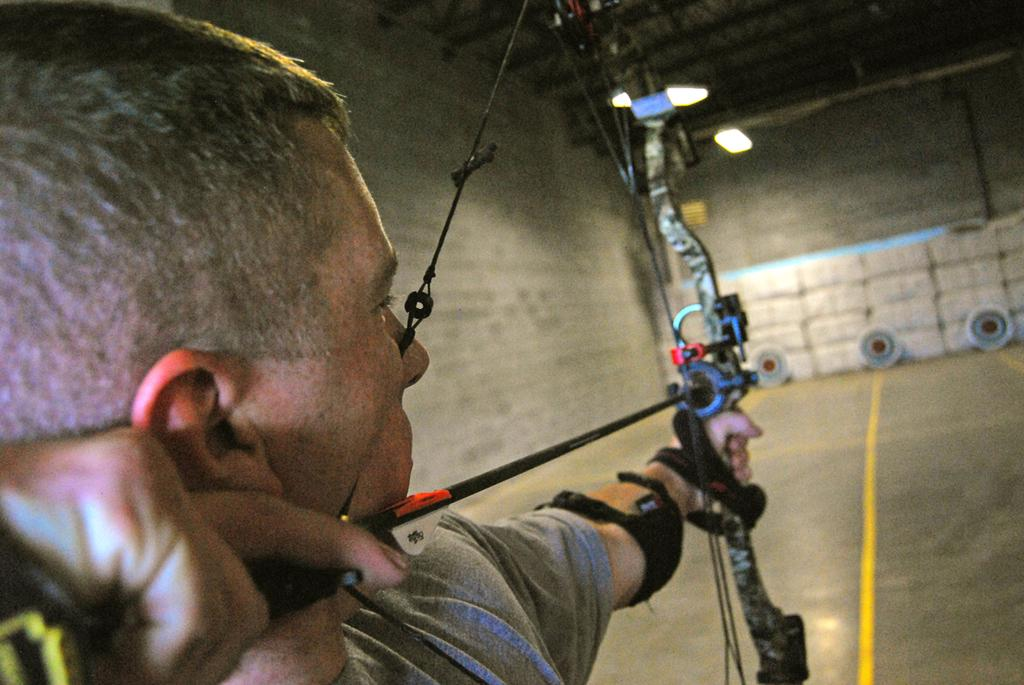What is the main subject in the foreground of the image? There is a man in the foreground of the image. What is the man holding in his hands? The man is holding a bow and an arrow. What can be seen in the background of the image? There is a wall of a shelter and targets on the floor in the background of the image. What type of office can be seen in the background of the image? There is no office present in the image; it features a wall of a shelter and targets on the floor. What shape are the targets on the floor in the image? The provided facts do not mention the shape of the targets, so we cannot determine their shape from the image. 